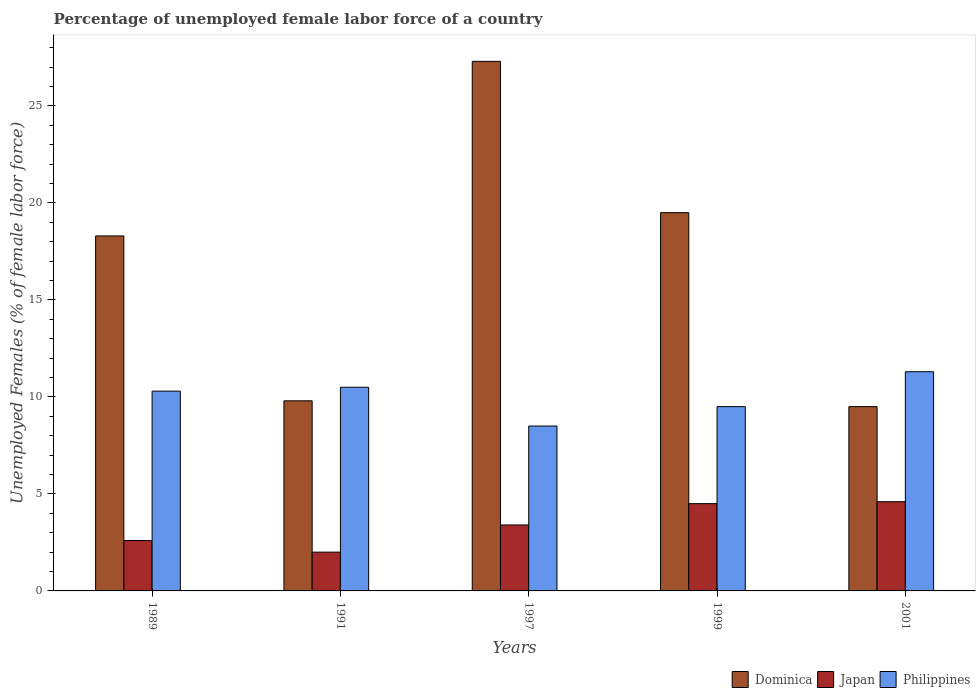How many bars are there on the 4th tick from the right?
Your answer should be very brief. 3. What is the percentage of unemployed female labor force in Philippines in 1989?
Give a very brief answer. 10.3. Across all years, what is the maximum percentage of unemployed female labor force in Japan?
Provide a short and direct response. 4.6. Across all years, what is the minimum percentage of unemployed female labor force in Philippines?
Give a very brief answer. 8.5. In which year was the percentage of unemployed female labor force in Japan maximum?
Your answer should be compact. 2001. What is the total percentage of unemployed female labor force in Japan in the graph?
Keep it short and to the point. 17.1. What is the difference between the percentage of unemployed female labor force in Philippines in 1997 and that in 1999?
Make the answer very short. -1. What is the difference between the percentage of unemployed female labor force in Dominica in 1997 and the percentage of unemployed female labor force in Japan in 1999?
Provide a short and direct response. 22.8. What is the average percentage of unemployed female labor force in Dominica per year?
Provide a short and direct response. 16.88. In the year 1997, what is the difference between the percentage of unemployed female labor force in Japan and percentage of unemployed female labor force in Philippines?
Provide a succinct answer. -5.1. What is the ratio of the percentage of unemployed female labor force in Philippines in 1989 to that in 1997?
Offer a terse response. 1.21. What is the difference between the highest and the second highest percentage of unemployed female labor force in Philippines?
Provide a short and direct response. 0.8. What is the difference between the highest and the lowest percentage of unemployed female labor force in Japan?
Your response must be concise. 2.6. In how many years, is the percentage of unemployed female labor force in Dominica greater than the average percentage of unemployed female labor force in Dominica taken over all years?
Offer a very short reply. 3. What does the 1st bar from the left in 2001 represents?
Keep it short and to the point. Dominica. Is it the case that in every year, the sum of the percentage of unemployed female labor force in Philippines and percentage of unemployed female labor force in Japan is greater than the percentage of unemployed female labor force in Dominica?
Offer a very short reply. No. How many bars are there?
Provide a succinct answer. 15. Are all the bars in the graph horizontal?
Provide a succinct answer. No. Does the graph contain any zero values?
Provide a short and direct response. No. Does the graph contain grids?
Offer a terse response. No. What is the title of the graph?
Provide a succinct answer. Percentage of unemployed female labor force of a country. Does "Virgin Islands" appear as one of the legend labels in the graph?
Offer a very short reply. No. What is the label or title of the X-axis?
Provide a succinct answer. Years. What is the label or title of the Y-axis?
Make the answer very short. Unemployed Females (% of female labor force). What is the Unemployed Females (% of female labor force) in Dominica in 1989?
Provide a short and direct response. 18.3. What is the Unemployed Females (% of female labor force) of Japan in 1989?
Make the answer very short. 2.6. What is the Unemployed Females (% of female labor force) in Philippines in 1989?
Make the answer very short. 10.3. What is the Unemployed Females (% of female labor force) in Dominica in 1991?
Offer a terse response. 9.8. What is the Unemployed Females (% of female labor force) of Japan in 1991?
Offer a terse response. 2. What is the Unemployed Females (% of female labor force) of Dominica in 1997?
Your answer should be compact. 27.3. What is the Unemployed Females (% of female labor force) in Japan in 1997?
Provide a succinct answer. 3.4. What is the Unemployed Females (% of female labor force) of Dominica in 1999?
Provide a short and direct response. 19.5. What is the Unemployed Females (% of female labor force) of Japan in 1999?
Your response must be concise. 4.5. What is the Unemployed Females (% of female labor force) of Philippines in 1999?
Give a very brief answer. 9.5. What is the Unemployed Females (% of female labor force) in Japan in 2001?
Your answer should be compact. 4.6. What is the Unemployed Females (% of female labor force) in Philippines in 2001?
Offer a terse response. 11.3. Across all years, what is the maximum Unemployed Females (% of female labor force) in Dominica?
Keep it short and to the point. 27.3. Across all years, what is the maximum Unemployed Females (% of female labor force) of Japan?
Make the answer very short. 4.6. Across all years, what is the maximum Unemployed Females (% of female labor force) of Philippines?
Offer a terse response. 11.3. What is the total Unemployed Females (% of female labor force) in Dominica in the graph?
Provide a succinct answer. 84.4. What is the total Unemployed Females (% of female labor force) of Japan in the graph?
Your response must be concise. 17.1. What is the total Unemployed Females (% of female labor force) of Philippines in the graph?
Keep it short and to the point. 50.1. What is the difference between the Unemployed Females (% of female labor force) in Philippines in 1989 and that in 1991?
Provide a short and direct response. -0.2. What is the difference between the Unemployed Females (% of female labor force) of Dominica in 1989 and that in 1997?
Offer a terse response. -9. What is the difference between the Unemployed Females (% of female labor force) in Philippines in 1989 and that in 1997?
Offer a terse response. 1.8. What is the difference between the Unemployed Females (% of female labor force) in Japan in 1989 and that in 1999?
Provide a short and direct response. -1.9. What is the difference between the Unemployed Females (% of female labor force) in Philippines in 1989 and that in 1999?
Make the answer very short. 0.8. What is the difference between the Unemployed Females (% of female labor force) of Philippines in 1989 and that in 2001?
Offer a very short reply. -1. What is the difference between the Unemployed Females (% of female labor force) in Dominica in 1991 and that in 1997?
Provide a succinct answer. -17.5. What is the difference between the Unemployed Females (% of female labor force) of Philippines in 1991 and that in 1997?
Give a very brief answer. 2. What is the difference between the Unemployed Females (% of female labor force) of Dominica in 1991 and that in 1999?
Give a very brief answer. -9.7. What is the difference between the Unemployed Females (% of female labor force) of Japan in 1991 and that in 1999?
Your response must be concise. -2.5. What is the difference between the Unemployed Females (% of female labor force) in Japan in 1991 and that in 2001?
Give a very brief answer. -2.6. What is the difference between the Unemployed Females (% of female labor force) in Japan in 1997 and that in 1999?
Your answer should be very brief. -1.1. What is the difference between the Unemployed Females (% of female labor force) of Japan in 1997 and that in 2001?
Provide a succinct answer. -1.2. What is the difference between the Unemployed Females (% of female labor force) in Japan in 1999 and that in 2001?
Your answer should be very brief. -0.1. What is the difference between the Unemployed Females (% of female labor force) in Dominica in 1989 and the Unemployed Females (% of female labor force) in Japan in 1991?
Make the answer very short. 16.3. What is the difference between the Unemployed Females (% of female labor force) of Dominica in 1989 and the Unemployed Females (% of female labor force) of Philippines in 1991?
Give a very brief answer. 7.8. What is the difference between the Unemployed Females (% of female labor force) in Dominica in 1989 and the Unemployed Females (% of female labor force) in Japan in 1997?
Provide a succinct answer. 14.9. What is the difference between the Unemployed Females (% of female labor force) in Dominica in 1989 and the Unemployed Females (% of female labor force) in Philippines in 1997?
Your answer should be very brief. 9.8. What is the difference between the Unemployed Females (% of female labor force) in Dominica in 1989 and the Unemployed Females (% of female labor force) in Japan in 1999?
Your answer should be very brief. 13.8. What is the difference between the Unemployed Females (% of female labor force) of Dominica in 1989 and the Unemployed Females (% of female labor force) of Japan in 2001?
Your response must be concise. 13.7. What is the difference between the Unemployed Females (% of female labor force) of Dominica in 1989 and the Unemployed Females (% of female labor force) of Philippines in 2001?
Your answer should be very brief. 7. What is the difference between the Unemployed Females (% of female labor force) in Dominica in 1991 and the Unemployed Females (% of female labor force) in Japan in 1997?
Your response must be concise. 6.4. What is the difference between the Unemployed Females (% of female labor force) in Japan in 1991 and the Unemployed Females (% of female labor force) in Philippines in 1997?
Keep it short and to the point. -6.5. What is the difference between the Unemployed Females (% of female labor force) in Dominica in 1991 and the Unemployed Females (% of female labor force) in Philippines in 1999?
Your answer should be very brief. 0.3. What is the difference between the Unemployed Females (% of female labor force) in Japan in 1991 and the Unemployed Females (% of female labor force) in Philippines in 1999?
Provide a short and direct response. -7.5. What is the difference between the Unemployed Females (% of female labor force) of Dominica in 1997 and the Unemployed Females (% of female labor force) of Japan in 1999?
Offer a terse response. 22.8. What is the difference between the Unemployed Females (% of female labor force) in Dominica in 1997 and the Unemployed Females (% of female labor force) in Philippines in 1999?
Ensure brevity in your answer.  17.8. What is the difference between the Unemployed Females (% of female labor force) of Japan in 1997 and the Unemployed Females (% of female labor force) of Philippines in 1999?
Ensure brevity in your answer.  -6.1. What is the difference between the Unemployed Females (% of female labor force) of Dominica in 1997 and the Unemployed Females (% of female labor force) of Japan in 2001?
Offer a terse response. 22.7. What is the difference between the Unemployed Females (% of female labor force) of Japan in 1997 and the Unemployed Females (% of female labor force) of Philippines in 2001?
Your response must be concise. -7.9. What is the average Unemployed Females (% of female labor force) of Dominica per year?
Provide a short and direct response. 16.88. What is the average Unemployed Females (% of female labor force) of Japan per year?
Provide a short and direct response. 3.42. What is the average Unemployed Females (% of female labor force) of Philippines per year?
Provide a short and direct response. 10.02. In the year 1989, what is the difference between the Unemployed Females (% of female labor force) of Japan and Unemployed Females (% of female labor force) of Philippines?
Make the answer very short. -7.7. In the year 1991, what is the difference between the Unemployed Females (% of female labor force) of Dominica and Unemployed Females (% of female labor force) of Philippines?
Provide a succinct answer. -0.7. In the year 1997, what is the difference between the Unemployed Females (% of female labor force) of Dominica and Unemployed Females (% of female labor force) of Japan?
Your response must be concise. 23.9. In the year 1999, what is the difference between the Unemployed Females (% of female labor force) in Dominica and Unemployed Females (% of female labor force) in Philippines?
Provide a short and direct response. 10. In the year 1999, what is the difference between the Unemployed Females (% of female labor force) of Japan and Unemployed Females (% of female labor force) of Philippines?
Provide a succinct answer. -5. In the year 2001, what is the difference between the Unemployed Females (% of female labor force) in Dominica and Unemployed Females (% of female labor force) in Japan?
Keep it short and to the point. 4.9. In the year 2001, what is the difference between the Unemployed Females (% of female labor force) of Japan and Unemployed Females (% of female labor force) of Philippines?
Your answer should be very brief. -6.7. What is the ratio of the Unemployed Females (% of female labor force) in Dominica in 1989 to that in 1991?
Provide a succinct answer. 1.87. What is the ratio of the Unemployed Females (% of female labor force) of Japan in 1989 to that in 1991?
Provide a succinct answer. 1.3. What is the ratio of the Unemployed Females (% of female labor force) in Philippines in 1989 to that in 1991?
Make the answer very short. 0.98. What is the ratio of the Unemployed Females (% of female labor force) of Dominica in 1989 to that in 1997?
Your response must be concise. 0.67. What is the ratio of the Unemployed Females (% of female labor force) of Japan in 1989 to that in 1997?
Provide a succinct answer. 0.76. What is the ratio of the Unemployed Females (% of female labor force) in Philippines in 1989 to that in 1997?
Make the answer very short. 1.21. What is the ratio of the Unemployed Females (% of female labor force) of Dominica in 1989 to that in 1999?
Make the answer very short. 0.94. What is the ratio of the Unemployed Females (% of female labor force) of Japan in 1989 to that in 1999?
Ensure brevity in your answer.  0.58. What is the ratio of the Unemployed Females (% of female labor force) in Philippines in 1989 to that in 1999?
Offer a terse response. 1.08. What is the ratio of the Unemployed Females (% of female labor force) in Dominica in 1989 to that in 2001?
Provide a short and direct response. 1.93. What is the ratio of the Unemployed Females (% of female labor force) of Japan in 1989 to that in 2001?
Make the answer very short. 0.57. What is the ratio of the Unemployed Females (% of female labor force) of Philippines in 1989 to that in 2001?
Your answer should be very brief. 0.91. What is the ratio of the Unemployed Females (% of female labor force) in Dominica in 1991 to that in 1997?
Make the answer very short. 0.36. What is the ratio of the Unemployed Females (% of female labor force) in Japan in 1991 to that in 1997?
Your answer should be compact. 0.59. What is the ratio of the Unemployed Females (% of female labor force) of Philippines in 1991 to that in 1997?
Your response must be concise. 1.24. What is the ratio of the Unemployed Females (% of female labor force) in Dominica in 1991 to that in 1999?
Give a very brief answer. 0.5. What is the ratio of the Unemployed Females (% of female labor force) of Japan in 1991 to that in 1999?
Your response must be concise. 0.44. What is the ratio of the Unemployed Females (% of female labor force) in Philippines in 1991 to that in 1999?
Ensure brevity in your answer.  1.11. What is the ratio of the Unemployed Females (% of female labor force) of Dominica in 1991 to that in 2001?
Offer a terse response. 1.03. What is the ratio of the Unemployed Females (% of female labor force) of Japan in 1991 to that in 2001?
Offer a terse response. 0.43. What is the ratio of the Unemployed Females (% of female labor force) in Philippines in 1991 to that in 2001?
Make the answer very short. 0.93. What is the ratio of the Unemployed Females (% of female labor force) of Japan in 1997 to that in 1999?
Ensure brevity in your answer.  0.76. What is the ratio of the Unemployed Females (% of female labor force) in Philippines in 1997 to that in 1999?
Your answer should be very brief. 0.89. What is the ratio of the Unemployed Females (% of female labor force) in Dominica in 1997 to that in 2001?
Give a very brief answer. 2.87. What is the ratio of the Unemployed Females (% of female labor force) in Japan in 1997 to that in 2001?
Offer a very short reply. 0.74. What is the ratio of the Unemployed Females (% of female labor force) of Philippines in 1997 to that in 2001?
Provide a succinct answer. 0.75. What is the ratio of the Unemployed Females (% of female labor force) of Dominica in 1999 to that in 2001?
Offer a terse response. 2.05. What is the ratio of the Unemployed Females (% of female labor force) of Japan in 1999 to that in 2001?
Your answer should be compact. 0.98. What is the ratio of the Unemployed Females (% of female labor force) in Philippines in 1999 to that in 2001?
Provide a short and direct response. 0.84. What is the difference between the highest and the lowest Unemployed Females (% of female labor force) of Dominica?
Make the answer very short. 17.8. What is the difference between the highest and the lowest Unemployed Females (% of female labor force) of Philippines?
Your response must be concise. 2.8. 